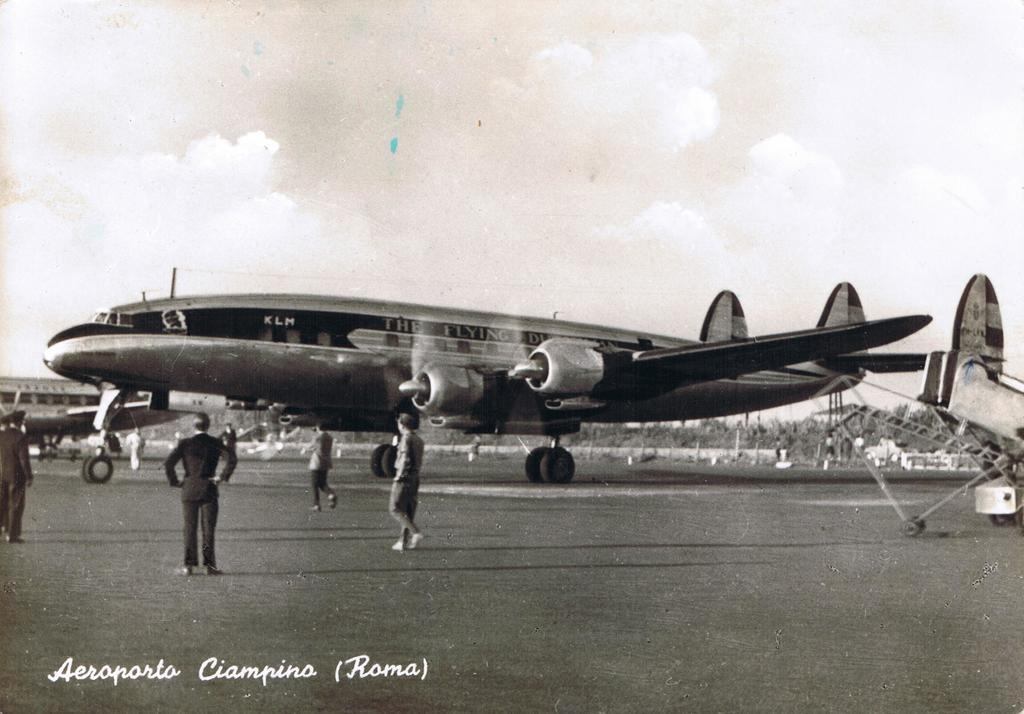<image>
Provide a brief description of the given image. An old picture of an airplane named after the Flying Dutchman in black and white 